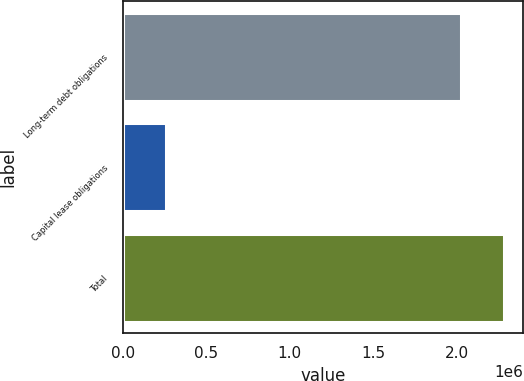<chart> <loc_0><loc_0><loc_500><loc_500><bar_chart><fcel>Long-term debt obligations<fcel>Capital lease obligations<fcel>Total<nl><fcel>2.025e+06<fcel>259534<fcel>2.28453e+06<nl></chart> 